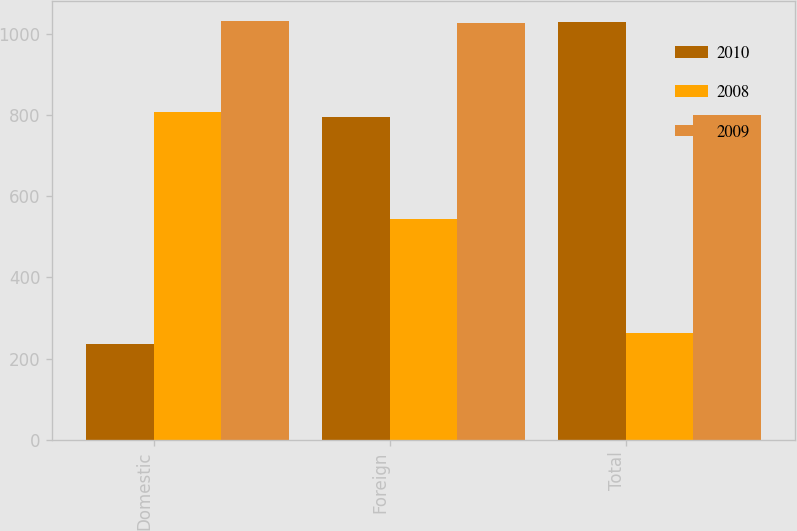Convert chart. <chart><loc_0><loc_0><loc_500><loc_500><stacked_bar_chart><ecel><fcel>Domestic<fcel>Foreign<fcel>Total<nl><fcel>2010<fcel>235<fcel>796<fcel>1031<nl><fcel>2008<fcel>808<fcel>544<fcel>264<nl><fcel>2009<fcel>1032<fcel>1029<fcel>802<nl></chart> 